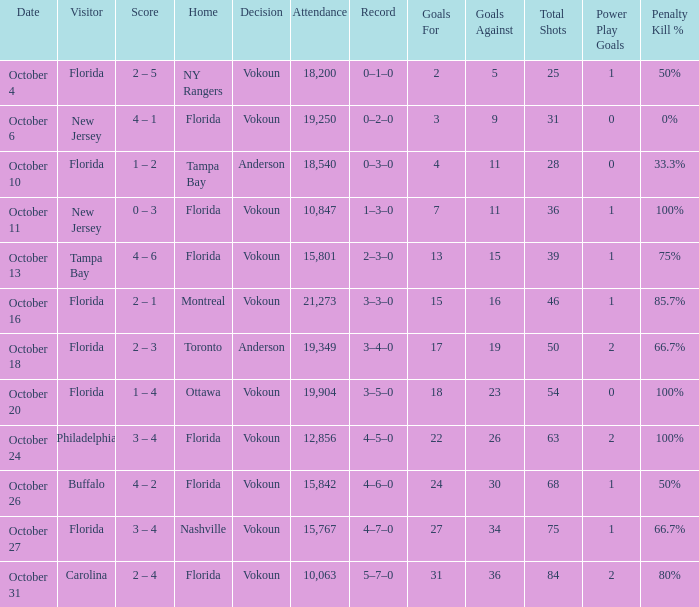Which team won when the visitor was Carolina? Vokoun. 